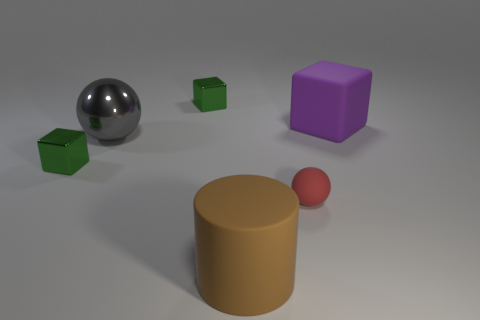Can you imagine a story involving these objects? In a quiet room filled with the soft light of dawn, the objects began to reveal their magical qualities. The silver sphere, known as the Mirror Orb, could show the reflection of one's true self, while the green cubes, called the Emerald Dice, determined one's fate with a roll. The majestic purple cube was the Royal Block, a talisman of wisdom and authority. The humble tan cylinder, the Pillar of Ages, stood as a guardian of history and knowledge. Lastly, the little red sphere, known as the Crimson Marble, held the power to grant a single, heartfelt wish. 